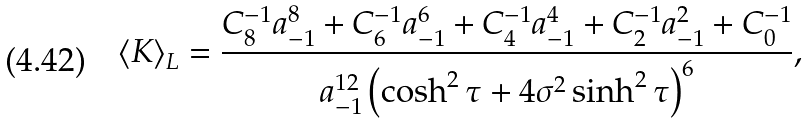Convert formula to latex. <formula><loc_0><loc_0><loc_500><loc_500>\left < K \right > _ { L } = { \frac { C _ { 8 } ^ { - 1 } a _ { - 1 } ^ { 8 } + C _ { 6 } ^ { - 1 } a _ { - 1 } ^ { 6 } + C _ { 4 } ^ { - 1 } a _ { - 1 } ^ { 4 } + C _ { 2 } ^ { - 1 } a _ { - 1 } ^ { 2 } + C _ { 0 } ^ { - 1 } } { a _ { - 1 } ^ { 1 2 } \left ( \cosh ^ { 2 } { \tau } + 4 \sigma ^ { 2 } \sinh ^ { 2 } { \tau } \right ) ^ { 6 } } } ,</formula> 